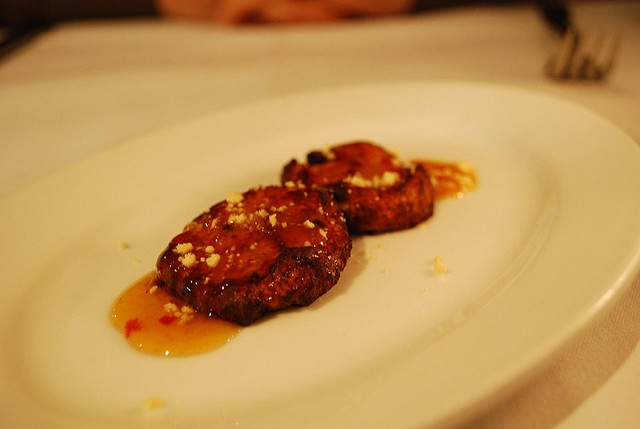Describe the objects in this image and their specific colors. I can see donut in black, maroon, and red tones, donut in black, maroon, and red tones, and fork in black, brown, and maroon tones in this image. 